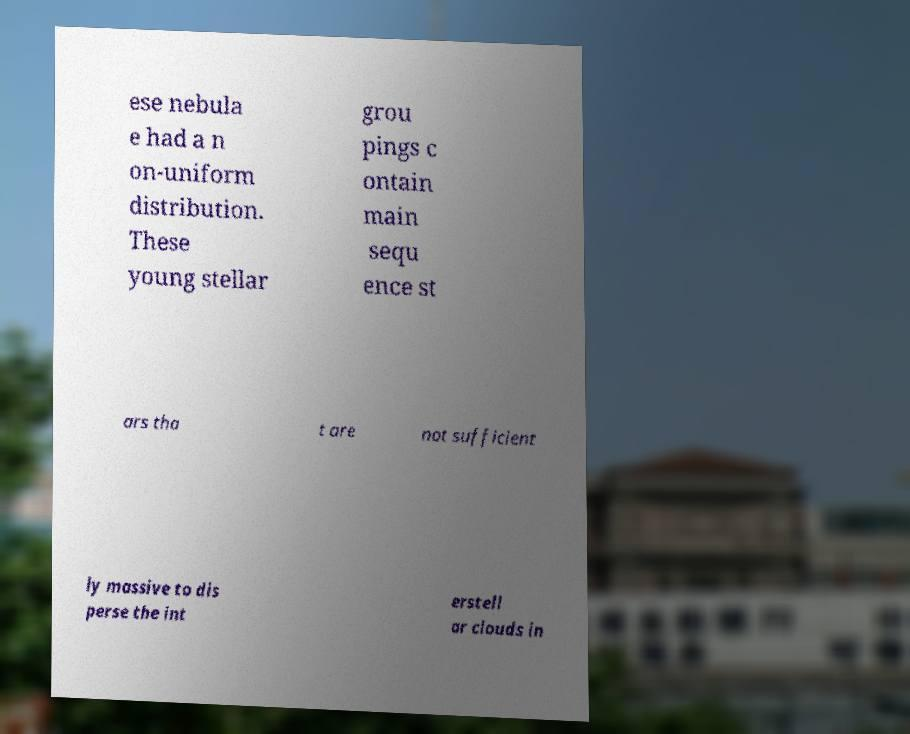Please identify and transcribe the text found in this image. ese nebula e had a n on-uniform distribution. These young stellar grou pings c ontain main sequ ence st ars tha t are not sufficient ly massive to dis perse the int erstell ar clouds in 